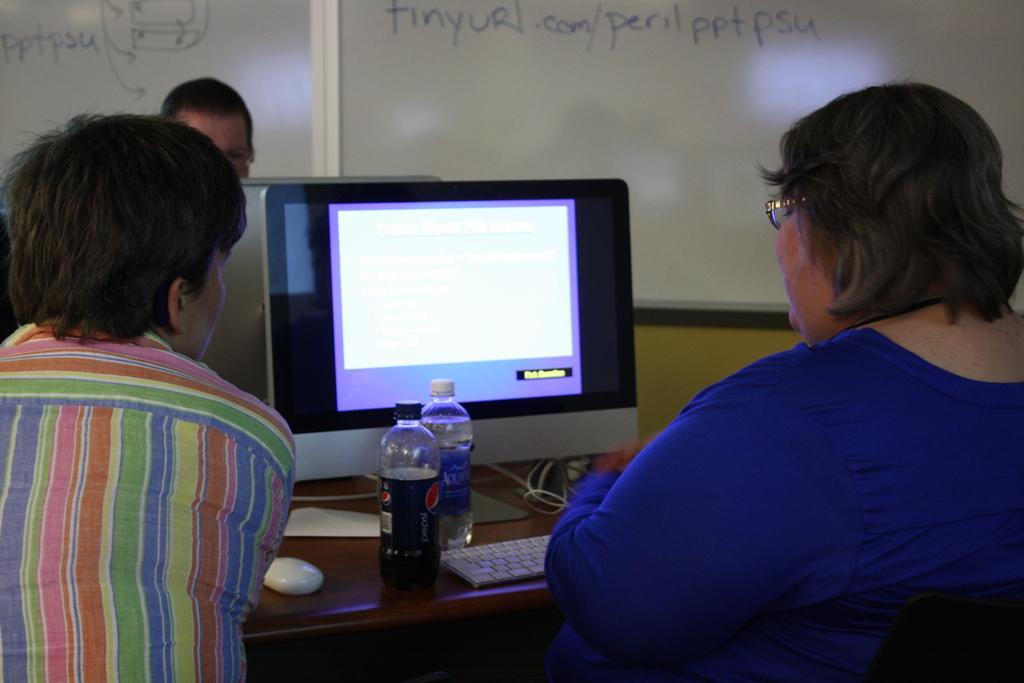In one or two sentences, can you explain what this image depicts? The image is taken in the room. On the right side there is a lady sitting. On the left there is a man. In the center of the image there is a table and a computer placed on the table. We can see some bottles and wires on the table. In the background there is a board. 